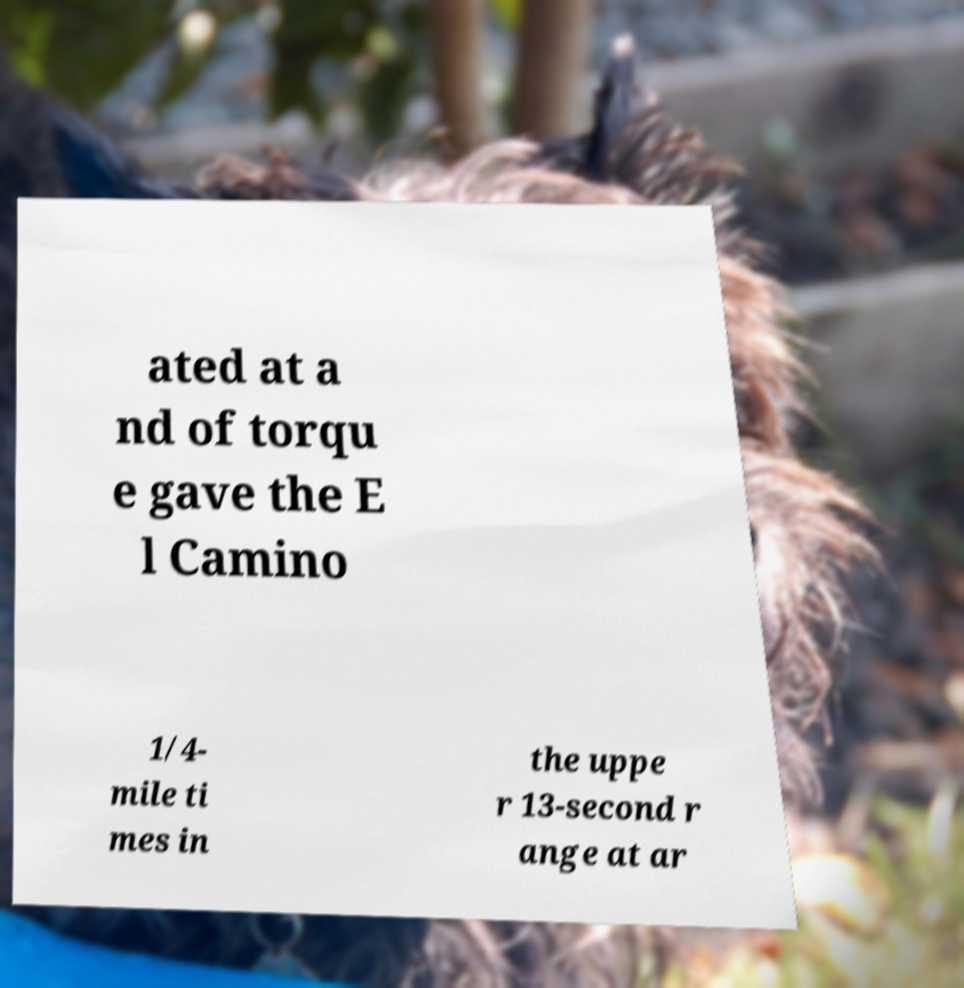Could you extract and type out the text from this image? ated at a nd of torqu e gave the E l Camino 1/4- mile ti mes in the uppe r 13-second r ange at ar 